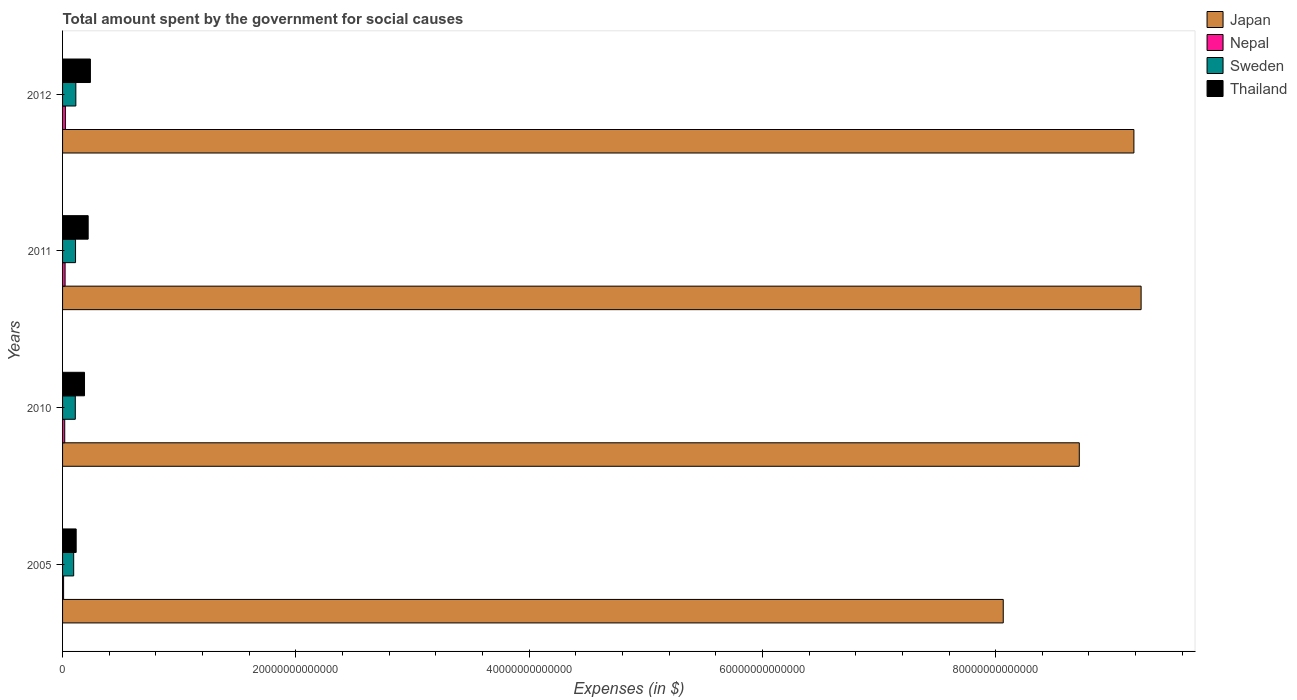How many groups of bars are there?
Offer a terse response. 4. Are the number of bars per tick equal to the number of legend labels?
Ensure brevity in your answer.  Yes. Are the number of bars on each tick of the Y-axis equal?
Keep it short and to the point. Yes. What is the label of the 4th group of bars from the top?
Provide a short and direct response. 2005. What is the amount spent for social causes by the government in Thailand in 2010?
Provide a short and direct response. 1.88e+12. Across all years, what is the maximum amount spent for social causes by the government in Thailand?
Keep it short and to the point. 2.39e+12. Across all years, what is the minimum amount spent for social causes by the government in Thailand?
Provide a succinct answer. 1.17e+12. What is the total amount spent for social causes by the government in Japan in the graph?
Provide a succinct answer. 3.52e+14. What is the difference between the amount spent for social causes by the government in Thailand in 2011 and that in 2012?
Your answer should be compact. -1.91e+11. What is the difference between the amount spent for social causes by the government in Japan in 2005 and the amount spent for social causes by the government in Nepal in 2011?
Your answer should be compact. 8.04e+13. What is the average amount spent for social causes by the government in Thailand per year?
Your answer should be very brief. 1.91e+12. In the year 2010, what is the difference between the amount spent for social causes by the government in Thailand and amount spent for social causes by the government in Sweden?
Your response must be concise. 7.90e+11. What is the ratio of the amount spent for social causes by the government in Thailand in 2010 to that in 2011?
Offer a very short reply. 0.86. Is the amount spent for social causes by the government in Japan in 2005 less than that in 2010?
Your answer should be very brief. Yes. Is the difference between the amount spent for social causes by the government in Thailand in 2005 and 2010 greater than the difference between the amount spent for social causes by the government in Sweden in 2005 and 2010?
Offer a terse response. No. What is the difference between the highest and the second highest amount spent for social causes by the government in Sweden?
Provide a short and direct response. 2.66e+1. What is the difference between the highest and the lowest amount spent for social causes by the government in Thailand?
Provide a succinct answer. 1.22e+12. In how many years, is the amount spent for social causes by the government in Thailand greater than the average amount spent for social causes by the government in Thailand taken over all years?
Offer a very short reply. 2. Is it the case that in every year, the sum of the amount spent for social causes by the government in Sweden and amount spent for social causes by the government in Nepal is greater than the sum of amount spent for social causes by the government in Japan and amount spent for social causes by the government in Thailand?
Give a very brief answer. No. What does the 3rd bar from the bottom in 2012 represents?
Your response must be concise. Sweden. Is it the case that in every year, the sum of the amount spent for social causes by the government in Nepal and amount spent for social causes by the government in Thailand is greater than the amount spent for social causes by the government in Sweden?
Provide a succinct answer. Yes. How many bars are there?
Provide a short and direct response. 16. How many years are there in the graph?
Give a very brief answer. 4. What is the difference between two consecutive major ticks on the X-axis?
Your answer should be very brief. 2.00e+13. Does the graph contain any zero values?
Make the answer very short. No. Where does the legend appear in the graph?
Give a very brief answer. Top right. How many legend labels are there?
Give a very brief answer. 4. How are the legend labels stacked?
Provide a succinct answer. Vertical. What is the title of the graph?
Keep it short and to the point. Total amount spent by the government for social causes. What is the label or title of the X-axis?
Ensure brevity in your answer.  Expenses (in $). What is the Expenses (in $) of Japan in 2005?
Your answer should be very brief. 8.07e+13. What is the Expenses (in $) in Nepal in 2005?
Keep it short and to the point. 8.88e+1. What is the Expenses (in $) in Sweden in 2005?
Provide a short and direct response. 9.54e+11. What is the Expenses (in $) of Thailand in 2005?
Your answer should be compact. 1.17e+12. What is the Expenses (in $) in Japan in 2010?
Keep it short and to the point. 8.72e+13. What is the Expenses (in $) in Nepal in 2010?
Your response must be concise. 1.86e+11. What is the Expenses (in $) in Sweden in 2010?
Provide a short and direct response. 1.09e+12. What is the Expenses (in $) in Thailand in 2010?
Provide a succinct answer. 1.88e+12. What is the Expenses (in $) of Japan in 2011?
Your answer should be very brief. 9.25e+13. What is the Expenses (in $) of Nepal in 2011?
Your answer should be very brief. 2.17e+11. What is the Expenses (in $) of Sweden in 2011?
Offer a very short reply. 1.11e+12. What is the Expenses (in $) in Thailand in 2011?
Your answer should be very brief. 2.20e+12. What is the Expenses (in $) of Japan in 2012?
Your answer should be very brief. 9.19e+13. What is the Expenses (in $) in Nepal in 2012?
Ensure brevity in your answer.  2.43e+11. What is the Expenses (in $) in Sweden in 2012?
Make the answer very short. 1.14e+12. What is the Expenses (in $) of Thailand in 2012?
Your answer should be compact. 2.39e+12. Across all years, what is the maximum Expenses (in $) in Japan?
Provide a short and direct response. 9.25e+13. Across all years, what is the maximum Expenses (in $) in Nepal?
Offer a very short reply. 2.43e+11. Across all years, what is the maximum Expenses (in $) in Sweden?
Provide a succinct answer. 1.14e+12. Across all years, what is the maximum Expenses (in $) in Thailand?
Provide a short and direct response. 2.39e+12. Across all years, what is the minimum Expenses (in $) of Japan?
Your answer should be very brief. 8.07e+13. Across all years, what is the minimum Expenses (in $) in Nepal?
Your answer should be compact. 8.88e+1. Across all years, what is the minimum Expenses (in $) in Sweden?
Your answer should be very brief. 9.54e+11. Across all years, what is the minimum Expenses (in $) in Thailand?
Keep it short and to the point. 1.17e+12. What is the total Expenses (in $) of Japan in the graph?
Provide a succinct answer. 3.52e+14. What is the total Expenses (in $) in Nepal in the graph?
Offer a terse response. 7.36e+11. What is the total Expenses (in $) in Sweden in the graph?
Provide a succinct answer. 4.30e+12. What is the total Expenses (in $) in Thailand in the graph?
Keep it short and to the point. 7.63e+12. What is the difference between the Expenses (in $) in Japan in 2005 and that in 2010?
Provide a succinct answer. -6.52e+12. What is the difference between the Expenses (in $) of Nepal in 2005 and that in 2010?
Make the answer very short. -9.77e+1. What is the difference between the Expenses (in $) of Sweden in 2005 and that in 2010?
Your answer should be very brief. -1.38e+11. What is the difference between the Expenses (in $) of Thailand in 2005 and that in 2010?
Keep it short and to the point. -7.16e+11. What is the difference between the Expenses (in $) of Japan in 2005 and that in 2011?
Provide a short and direct response. -1.18e+13. What is the difference between the Expenses (in $) of Nepal in 2005 and that in 2011?
Offer a very short reply. -1.29e+11. What is the difference between the Expenses (in $) in Sweden in 2005 and that in 2011?
Provide a short and direct response. -1.58e+11. What is the difference between the Expenses (in $) in Thailand in 2005 and that in 2011?
Ensure brevity in your answer.  -1.03e+12. What is the difference between the Expenses (in $) of Japan in 2005 and that in 2012?
Your answer should be very brief. -1.12e+13. What is the difference between the Expenses (in $) in Nepal in 2005 and that in 2012?
Offer a very short reply. -1.55e+11. What is the difference between the Expenses (in $) of Sweden in 2005 and that in 2012?
Your response must be concise. -1.85e+11. What is the difference between the Expenses (in $) of Thailand in 2005 and that in 2012?
Make the answer very short. -1.22e+12. What is the difference between the Expenses (in $) of Japan in 2010 and that in 2011?
Your answer should be very brief. -5.30e+12. What is the difference between the Expenses (in $) of Nepal in 2010 and that in 2011?
Your response must be concise. -3.08e+1. What is the difference between the Expenses (in $) of Sweden in 2010 and that in 2011?
Offer a terse response. -2.03e+1. What is the difference between the Expenses (in $) of Thailand in 2010 and that in 2011?
Make the answer very short. -3.14e+11. What is the difference between the Expenses (in $) of Japan in 2010 and that in 2012?
Ensure brevity in your answer.  -4.68e+12. What is the difference between the Expenses (in $) of Nepal in 2010 and that in 2012?
Keep it short and to the point. -5.69e+1. What is the difference between the Expenses (in $) of Sweden in 2010 and that in 2012?
Offer a very short reply. -4.70e+1. What is the difference between the Expenses (in $) of Thailand in 2010 and that in 2012?
Your answer should be compact. -5.05e+11. What is the difference between the Expenses (in $) in Japan in 2011 and that in 2012?
Your response must be concise. 6.18e+11. What is the difference between the Expenses (in $) in Nepal in 2011 and that in 2012?
Make the answer very short. -2.60e+1. What is the difference between the Expenses (in $) of Sweden in 2011 and that in 2012?
Your answer should be very brief. -2.66e+1. What is the difference between the Expenses (in $) of Thailand in 2011 and that in 2012?
Offer a terse response. -1.91e+11. What is the difference between the Expenses (in $) in Japan in 2005 and the Expenses (in $) in Nepal in 2010?
Keep it short and to the point. 8.05e+13. What is the difference between the Expenses (in $) of Japan in 2005 and the Expenses (in $) of Sweden in 2010?
Your response must be concise. 7.96e+13. What is the difference between the Expenses (in $) in Japan in 2005 and the Expenses (in $) in Thailand in 2010?
Provide a succinct answer. 7.88e+13. What is the difference between the Expenses (in $) of Nepal in 2005 and the Expenses (in $) of Sweden in 2010?
Make the answer very short. -1.00e+12. What is the difference between the Expenses (in $) of Nepal in 2005 and the Expenses (in $) of Thailand in 2010?
Provide a short and direct response. -1.79e+12. What is the difference between the Expenses (in $) in Sweden in 2005 and the Expenses (in $) in Thailand in 2010?
Give a very brief answer. -9.28e+11. What is the difference between the Expenses (in $) of Japan in 2005 and the Expenses (in $) of Nepal in 2011?
Keep it short and to the point. 8.04e+13. What is the difference between the Expenses (in $) of Japan in 2005 and the Expenses (in $) of Sweden in 2011?
Your answer should be very brief. 7.95e+13. What is the difference between the Expenses (in $) of Japan in 2005 and the Expenses (in $) of Thailand in 2011?
Your answer should be very brief. 7.85e+13. What is the difference between the Expenses (in $) in Nepal in 2005 and the Expenses (in $) in Sweden in 2011?
Provide a succinct answer. -1.02e+12. What is the difference between the Expenses (in $) of Nepal in 2005 and the Expenses (in $) of Thailand in 2011?
Ensure brevity in your answer.  -2.11e+12. What is the difference between the Expenses (in $) of Sweden in 2005 and the Expenses (in $) of Thailand in 2011?
Your answer should be very brief. -1.24e+12. What is the difference between the Expenses (in $) in Japan in 2005 and the Expenses (in $) in Nepal in 2012?
Give a very brief answer. 8.04e+13. What is the difference between the Expenses (in $) in Japan in 2005 and the Expenses (in $) in Sweden in 2012?
Keep it short and to the point. 7.95e+13. What is the difference between the Expenses (in $) in Japan in 2005 and the Expenses (in $) in Thailand in 2012?
Provide a succinct answer. 7.83e+13. What is the difference between the Expenses (in $) of Nepal in 2005 and the Expenses (in $) of Sweden in 2012?
Offer a terse response. -1.05e+12. What is the difference between the Expenses (in $) of Nepal in 2005 and the Expenses (in $) of Thailand in 2012?
Provide a short and direct response. -2.30e+12. What is the difference between the Expenses (in $) in Sweden in 2005 and the Expenses (in $) in Thailand in 2012?
Keep it short and to the point. -1.43e+12. What is the difference between the Expenses (in $) of Japan in 2010 and the Expenses (in $) of Nepal in 2011?
Offer a terse response. 8.70e+13. What is the difference between the Expenses (in $) of Japan in 2010 and the Expenses (in $) of Sweden in 2011?
Ensure brevity in your answer.  8.61e+13. What is the difference between the Expenses (in $) in Japan in 2010 and the Expenses (in $) in Thailand in 2011?
Your answer should be compact. 8.50e+13. What is the difference between the Expenses (in $) of Nepal in 2010 and the Expenses (in $) of Sweden in 2011?
Your answer should be compact. -9.26e+11. What is the difference between the Expenses (in $) of Nepal in 2010 and the Expenses (in $) of Thailand in 2011?
Ensure brevity in your answer.  -2.01e+12. What is the difference between the Expenses (in $) in Sweden in 2010 and the Expenses (in $) in Thailand in 2011?
Ensure brevity in your answer.  -1.10e+12. What is the difference between the Expenses (in $) in Japan in 2010 and the Expenses (in $) in Nepal in 2012?
Offer a terse response. 8.69e+13. What is the difference between the Expenses (in $) of Japan in 2010 and the Expenses (in $) of Sweden in 2012?
Your response must be concise. 8.60e+13. What is the difference between the Expenses (in $) of Japan in 2010 and the Expenses (in $) of Thailand in 2012?
Ensure brevity in your answer.  8.48e+13. What is the difference between the Expenses (in $) in Nepal in 2010 and the Expenses (in $) in Sweden in 2012?
Provide a succinct answer. -9.53e+11. What is the difference between the Expenses (in $) in Nepal in 2010 and the Expenses (in $) in Thailand in 2012?
Ensure brevity in your answer.  -2.20e+12. What is the difference between the Expenses (in $) in Sweden in 2010 and the Expenses (in $) in Thailand in 2012?
Ensure brevity in your answer.  -1.29e+12. What is the difference between the Expenses (in $) of Japan in 2011 and the Expenses (in $) of Nepal in 2012?
Offer a terse response. 9.22e+13. What is the difference between the Expenses (in $) of Japan in 2011 and the Expenses (in $) of Sweden in 2012?
Ensure brevity in your answer.  9.13e+13. What is the difference between the Expenses (in $) in Japan in 2011 and the Expenses (in $) in Thailand in 2012?
Your response must be concise. 9.01e+13. What is the difference between the Expenses (in $) in Nepal in 2011 and the Expenses (in $) in Sweden in 2012?
Offer a very short reply. -9.22e+11. What is the difference between the Expenses (in $) in Nepal in 2011 and the Expenses (in $) in Thailand in 2012?
Offer a terse response. -2.17e+12. What is the difference between the Expenses (in $) of Sweden in 2011 and the Expenses (in $) of Thailand in 2012?
Give a very brief answer. -1.27e+12. What is the average Expenses (in $) of Japan per year?
Offer a terse response. 8.80e+13. What is the average Expenses (in $) in Nepal per year?
Make the answer very short. 1.84e+11. What is the average Expenses (in $) of Sweden per year?
Offer a very short reply. 1.07e+12. What is the average Expenses (in $) in Thailand per year?
Your answer should be compact. 1.91e+12. In the year 2005, what is the difference between the Expenses (in $) of Japan and Expenses (in $) of Nepal?
Your answer should be very brief. 8.06e+13. In the year 2005, what is the difference between the Expenses (in $) in Japan and Expenses (in $) in Sweden?
Provide a short and direct response. 7.97e+13. In the year 2005, what is the difference between the Expenses (in $) of Japan and Expenses (in $) of Thailand?
Your answer should be very brief. 7.95e+13. In the year 2005, what is the difference between the Expenses (in $) of Nepal and Expenses (in $) of Sweden?
Your answer should be very brief. -8.65e+11. In the year 2005, what is the difference between the Expenses (in $) of Nepal and Expenses (in $) of Thailand?
Provide a short and direct response. -1.08e+12. In the year 2005, what is the difference between the Expenses (in $) in Sweden and Expenses (in $) in Thailand?
Make the answer very short. -2.12e+11. In the year 2010, what is the difference between the Expenses (in $) in Japan and Expenses (in $) in Nepal?
Give a very brief answer. 8.70e+13. In the year 2010, what is the difference between the Expenses (in $) of Japan and Expenses (in $) of Sweden?
Ensure brevity in your answer.  8.61e+13. In the year 2010, what is the difference between the Expenses (in $) in Japan and Expenses (in $) in Thailand?
Give a very brief answer. 8.53e+13. In the year 2010, what is the difference between the Expenses (in $) of Nepal and Expenses (in $) of Sweden?
Make the answer very short. -9.06e+11. In the year 2010, what is the difference between the Expenses (in $) of Nepal and Expenses (in $) of Thailand?
Make the answer very short. -1.70e+12. In the year 2010, what is the difference between the Expenses (in $) of Sweden and Expenses (in $) of Thailand?
Offer a terse response. -7.90e+11. In the year 2011, what is the difference between the Expenses (in $) of Japan and Expenses (in $) of Nepal?
Offer a very short reply. 9.23e+13. In the year 2011, what is the difference between the Expenses (in $) in Japan and Expenses (in $) in Sweden?
Your response must be concise. 9.14e+13. In the year 2011, what is the difference between the Expenses (in $) of Japan and Expenses (in $) of Thailand?
Offer a terse response. 9.03e+13. In the year 2011, what is the difference between the Expenses (in $) in Nepal and Expenses (in $) in Sweden?
Keep it short and to the point. -8.95e+11. In the year 2011, what is the difference between the Expenses (in $) in Nepal and Expenses (in $) in Thailand?
Provide a succinct answer. -1.98e+12. In the year 2011, what is the difference between the Expenses (in $) of Sweden and Expenses (in $) of Thailand?
Give a very brief answer. -1.08e+12. In the year 2012, what is the difference between the Expenses (in $) in Japan and Expenses (in $) in Nepal?
Your response must be concise. 9.16e+13. In the year 2012, what is the difference between the Expenses (in $) of Japan and Expenses (in $) of Sweden?
Keep it short and to the point. 9.07e+13. In the year 2012, what is the difference between the Expenses (in $) in Japan and Expenses (in $) in Thailand?
Provide a succinct answer. 8.95e+13. In the year 2012, what is the difference between the Expenses (in $) in Nepal and Expenses (in $) in Sweden?
Offer a very short reply. -8.96e+11. In the year 2012, what is the difference between the Expenses (in $) in Nepal and Expenses (in $) in Thailand?
Ensure brevity in your answer.  -2.14e+12. In the year 2012, what is the difference between the Expenses (in $) in Sweden and Expenses (in $) in Thailand?
Your response must be concise. -1.25e+12. What is the ratio of the Expenses (in $) of Japan in 2005 to that in 2010?
Offer a very short reply. 0.93. What is the ratio of the Expenses (in $) in Nepal in 2005 to that in 2010?
Your response must be concise. 0.48. What is the ratio of the Expenses (in $) in Sweden in 2005 to that in 2010?
Provide a succinct answer. 0.87. What is the ratio of the Expenses (in $) in Thailand in 2005 to that in 2010?
Make the answer very short. 0.62. What is the ratio of the Expenses (in $) of Japan in 2005 to that in 2011?
Provide a short and direct response. 0.87. What is the ratio of the Expenses (in $) of Nepal in 2005 to that in 2011?
Ensure brevity in your answer.  0.41. What is the ratio of the Expenses (in $) in Sweden in 2005 to that in 2011?
Offer a very short reply. 0.86. What is the ratio of the Expenses (in $) of Thailand in 2005 to that in 2011?
Offer a terse response. 0.53. What is the ratio of the Expenses (in $) in Japan in 2005 to that in 2012?
Your response must be concise. 0.88. What is the ratio of the Expenses (in $) of Nepal in 2005 to that in 2012?
Offer a very short reply. 0.36. What is the ratio of the Expenses (in $) of Sweden in 2005 to that in 2012?
Offer a very short reply. 0.84. What is the ratio of the Expenses (in $) of Thailand in 2005 to that in 2012?
Provide a short and direct response. 0.49. What is the ratio of the Expenses (in $) in Japan in 2010 to that in 2011?
Make the answer very short. 0.94. What is the ratio of the Expenses (in $) in Nepal in 2010 to that in 2011?
Ensure brevity in your answer.  0.86. What is the ratio of the Expenses (in $) in Sweden in 2010 to that in 2011?
Your response must be concise. 0.98. What is the ratio of the Expenses (in $) in Thailand in 2010 to that in 2011?
Provide a short and direct response. 0.86. What is the ratio of the Expenses (in $) in Japan in 2010 to that in 2012?
Keep it short and to the point. 0.95. What is the ratio of the Expenses (in $) in Nepal in 2010 to that in 2012?
Provide a short and direct response. 0.77. What is the ratio of the Expenses (in $) in Sweden in 2010 to that in 2012?
Offer a terse response. 0.96. What is the ratio of the Expenses (in $) of Thailand in 2010 to that in 2012?
Give a very brief answer. 0.79. What is the ratio of the Expenses (in $) of Nepal in 2011 to that in 2012?
Offer a very short reply. 0.89. What is the ratio of the Expenses (in $) in Sweden in 2011 to that in 2012?
Your response must be concise. 0.98. What is the ratio of the Expenses (in $) in Thailand in 2011 to that in 2012?
Keep it short and to the point. 0.92. What is the difference between the highest and the second highest Expenses (in $) of Japan?
Offer a very short reply. 6.18e+11. What is the difference between the highest and the second highest Expenses (in $) of Nepal?
Your answer should be very brief. 2.60e+1. What is the difference between the highest and the second highest Expenses (in $) in Sweden?
Offer a very short reply. 2.66e+1. What is the difference between the highest and the second highest Expenses (in $) of Thailand?
Offer a very short reply. 1.91e+11. What is the difference between the highest and the lowest Expenses (in $) of Japan?
Your response must be concise. 1.18e+13. What is the difference between the highest and the lowest Expenses (in $) in Nepal?
Ensure brevity in your answer.  1.55e+11. What is the difference between the highest and the lowest Expenses (in $) of Sweden?
Your response must be concise. 1.85e+11. What is the difference between the highest and the lowest Expenses (in $) in Thailand?
Give a very brief answer. 1.22e+12. 